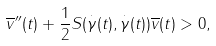Convert formula to latex. <formula><loc_0><loc_0><loc_500><loc_500>\overline { v } ^ { \prime \prime } ( t ) + \frac { 1 } { 2 } S ( \overset { \cdot } { \gamma } ( t ) , \overset { \cdot } { \gamma } ( t ) ) \overline { v } ( t ) > 0 ,</formula> 